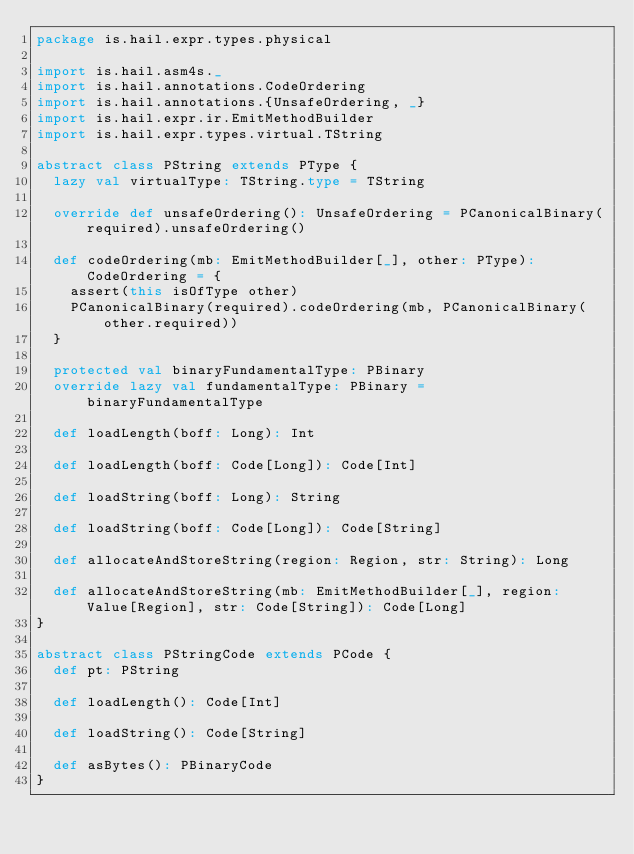Convert code to text. <code><loc_0><loc_0><loc_500><loc_500><_Scala_>package is.hail.expr.types.physical

import is.hail.asm4s._
import is.hail.annotations.CodeOrdering
import is.hail.annotations.{UnsafeOrdering, _}
import is.hail.expr.ir.EmitMethodBuilder
import is.hail.expr.types.virtual.TString

abstract class PString extends PType {
  lazy val virtualType: TString.type = TString

  override def unsafeOrdering(): UnsafeOrdering = PCanonicalBinary(required).unsafeOrdering()

  def codeOrdering(mb: EmitMethodBuilder[_], other: PType): CodeOrdering = {
    assert(this isOfType other)
    PCanonicalBinary(required).codeOrdering(mb, PCanonicalBinary(other.required))
  }

  protected val binaryFundamentalType: PBinary
  override lazy val fundamentalType: PBinary = binaryFundamentalType

  def loadLength(boff: Long): Int

  def loadLength(boff: Code[Long]): Code[Int]

  def loadString(boff: Long): String

  def loadString(boff: Code[Long]): Code[String]

  def allocateAndStoreString(region: Region, str: String): Long

  def allocateAndStoreString(mb: EmitMethodBuilder[_], region: Value[Region], str: Code[String]): Code[Long]
}

abstract class PStringCode extends PCode {
  def pt: PString

  def loadLength(): Code[Int]

  def loadString(): Code[String]

  def asBytes(): PBinaryCode
}
</code> 